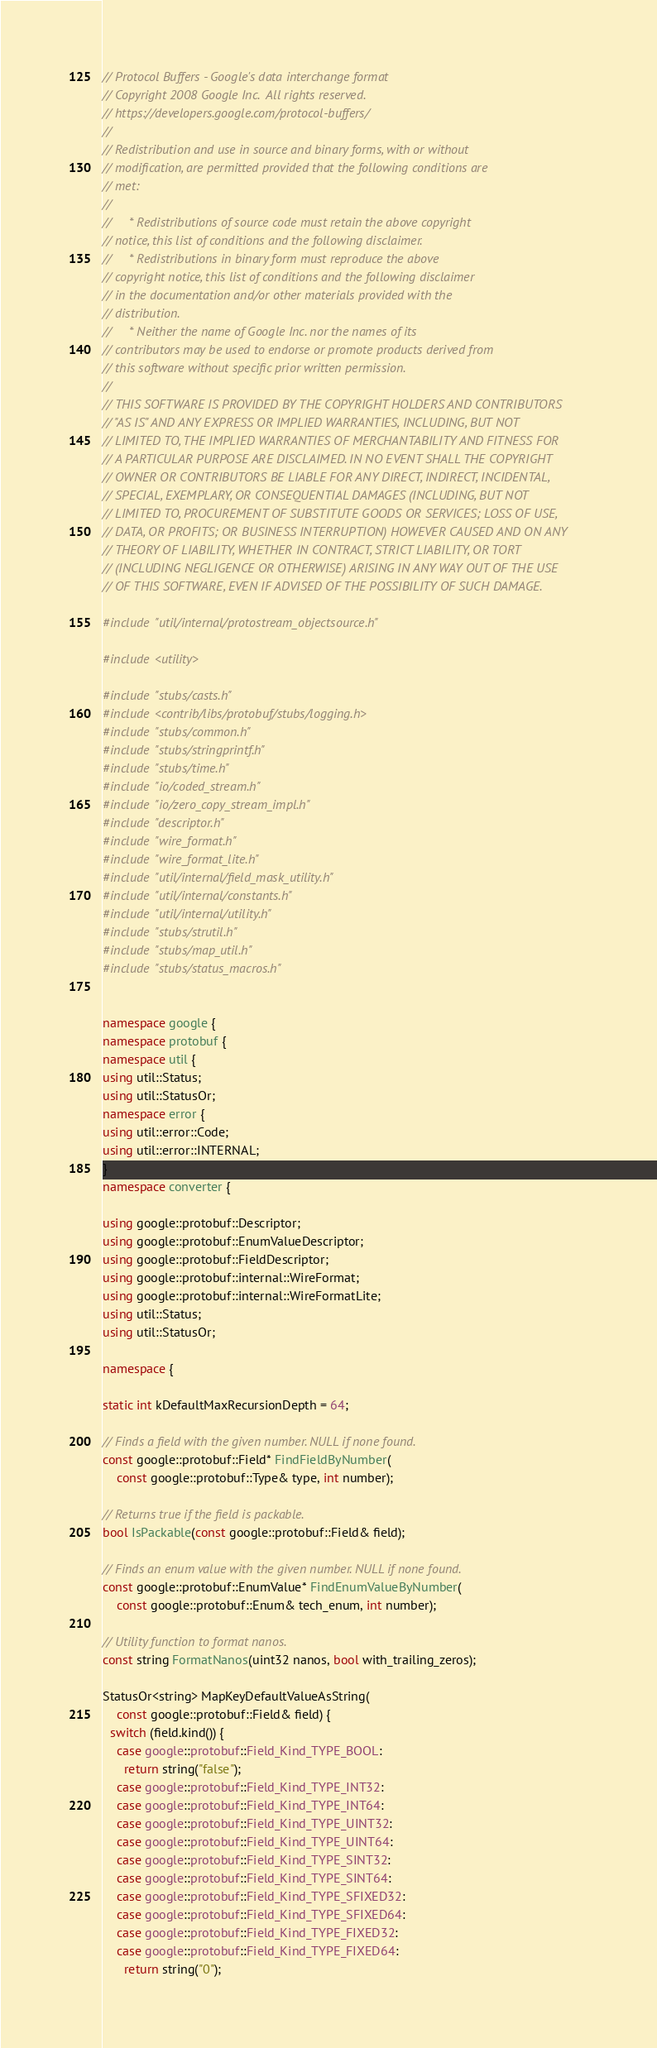<code> <loc_0><loc_0><loc_500><loc_500><_C++_>// Protocol Buffers - Google's data interchange format
// Copyright 2008 Google Inc.  All rights reserved.
// https://developers.google.com/protocol-buffers/
//
// Redistribution and use in source and binary forms, with or without
// modification, are permitted provided that the following conditions are
// met:
//
//     * Redistributions of source code must retain the above copyright
// notice, this list of conditions and the following disclaimer.
//     * Redistributions in binary form must reproduce the above
// copyright notice, this list of conditions and the following disclaimer
// in the documentation and/or other materials provided with the
// distribution.
//     * Neither the name of Google Inc. nor the names of its
// contributors may be used to endorse or promote products derived from
// this software without specific prior written permission.
//
// THIS SOFTWARE IS PROVIDED BY THE COPYRIGHT HOLDERS AND CONTRIBUTORS
// "AS IS" AND ANY EXPRESS OR IMPLIED WARRANTIES, INCLUDING, BUT NOT
// LIMITED TO, THE IMPLIED WARRANTIES OF MERCHANTABILITY AND FITNESS FOR
// A PARTICULAR PURPOSE ARE DISCLAIMED. IN NO EVENT SHALL THE COPYRIGHT
// OWNER OR CONTRIBUTORS BE LIABLE FOR ANY DIRECT, INDIRECT, INCIDENTAL,
// SPECIAL, EXEMPLARY, OR CONSEQUENTIAL DAMAGES (INCLUDING, BUT NOT
// LIMITED TO, PROCUREMENT OF SUBSTITUTE GOODS OR SERVICES; LOSS OF USE,
// DATA, OR PROFITS; OR BUSINESS INTERRUPTION) HOWEVER CAUSED AND ON ANY
// THEORY OF LIABILITY, WHETHER IN CONTRACT, STRICT LIABILITY, OR TORT
// (INCLUDING NEGLIGENCE OR OTHERWISE) ARISING IN ANY WAY OUT OF THE USE
// OF THIS SOFTWARE, EVEN IF ADVISED OF THE POSSIBILITY OF SUCH DAMAGE.

#include "util/internal/protostream_objectsource.h"

#include <utility>

#include "stubs/casts.h"
#include <contrib/libs/protobuf/stubs/logging.h>
#include "stubs/common.h"
#include "stubs/stringprintf.h"
#include "stubs/time.h"
#include "io/coded_stream.h"
#include "io/zero_copy_stream_impl.h"
#include "descriptor.h"
#include "wire_format.h"
#include "wire_format_lite.h"
#include "util/internal/field_mask_utility.h"
#include "util/internal/constants.h"
#include "util/internal/utility.h"
#include "stubs/strutil.h"
#include "stubs/map_util.h"
#include "stubs/status_macros.h"


namespace google {
namespace protobuf {
namespace util {
using util::Status;
using util::StatusOr;
namespace error {
using util::error::Code;
using util::error::INTERNAL;
}
namespace converter {

using google::protobuf::Descriptor;
using google::protobuf::EnumValueDescriptor;
using google::protobuf::FieldDescriptor;
using google::protobuf::internal::WireFormat;
using google::protobuf::internal::WireFormatLite;
using util::Status;
using util::StatusOr;

namespace {

static int kDefaultMaxRecursionDepth = 64;

// Finds a field with the given number. NULL if none found.
const google::protobuf::Field* FindFieldByNumber(
    const google::protobuf::Type& type, int number);

// Returns true if the field is packable.
bool IsPackable(const google::protobuf::Field& field);

// Finds an enum value with the given number. NULL if none found.
const google::protobuf::EnumValue* FindEnumValueByNumber(
    const google::protobuf::Enum& tech_enum, int number);

// Utility function to format nanos.
const string FormatNanos(uint32 nanos, bool with_trailing_zeros);

StatusOr<string> MapKeyDefaultValueAsString(
    const google::protobuf::Field& field) {
  switch (field.kind()) {
    case google::protobuf::Field_Kind_TYPE_BOOL:
      return string("false");
    case google::protobuf::Field_Kind_TYPE_INT32:
    case google::protobuf::Field_Kind_TYPE_INT64:
    case google::protobuf::Field_Kind_TYPE_UINT32:
    case google::protobuf::Field_Kind_TYPE_UINT64:
    case google::protobuf::Field_Kind_TYPE_SINT32:
    case google::protobuf::Field_Kind_TYPE_SINT64:
    case google::protobuf::Field_Kind_TYPE_SFIXED32:
    case google::protobuf::Field_Kind_TYPE_SFIXED64:
    case google::protobuf::Field_Kind_TYPE_FIXED32:
    case google::protobuf::Field_Kind_TYPE_FIXED64:
      return string("0");</code> 